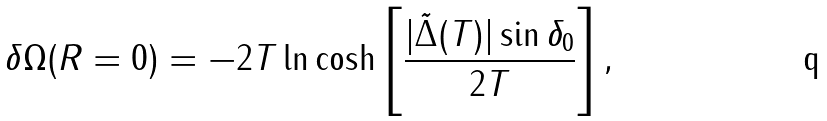Convert formula to latex. <formula><loc_0><loc_0><loc_500><loc_500>\delta \Omega ( R = 0 ) = - 2 T \ln \cosh \left [ \frac { | { \tilde { \Delta } } ( T ) | \sin \delta _ { 0 } } { 2 T } \right ] ,</formula> 